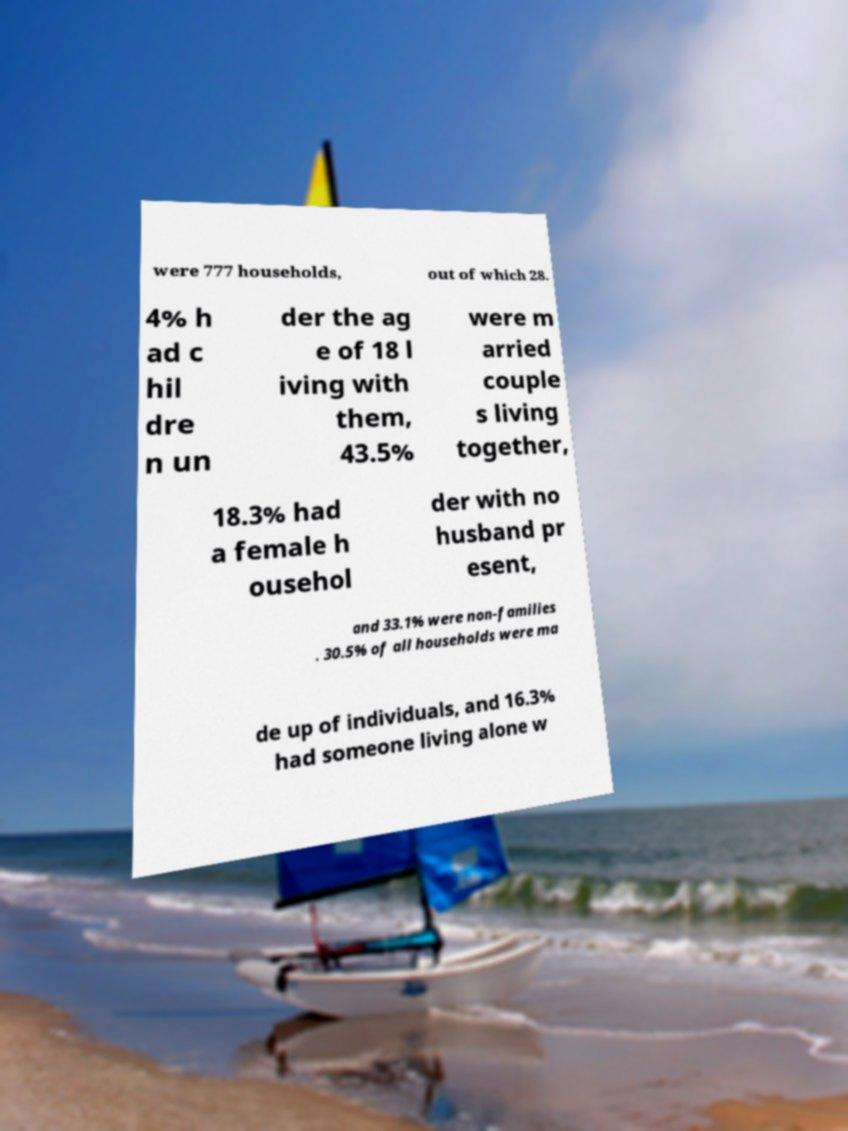I need the written content from this picture converted into text. Can you do that? were 777 households, out of which 28. 4% h ad c hil dre n un der the ag e of 18 l iving with them, 43.5% were m arried couple s living together, 18.3% had a female h ousehol der with no husband pr esent, and 33.1% were non-families . 30.5% of all households were ma de up of individuals, and 16.3% had someone living alone w 